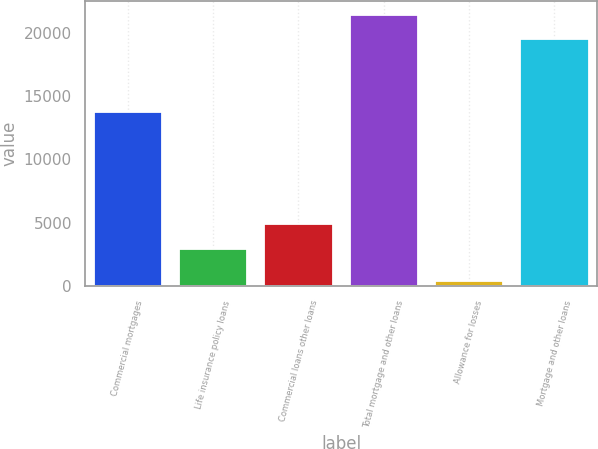Convert chart. <chart><loc_0><loc_0><loc_500><loc_500><bar_chart><fcel>Commercial mortgages<fcel>Life insurance policy loans<fcel>Commercial loans other loans<fcel>Total mortgage and other loans<fcel>Allowance for losses<fcel>Mortgage and other loans<nl><fcel>13788<fcel>2952<fcel>4900.2<fcel>21430.2<fcel>405<fcel>19482<nl></chart> 